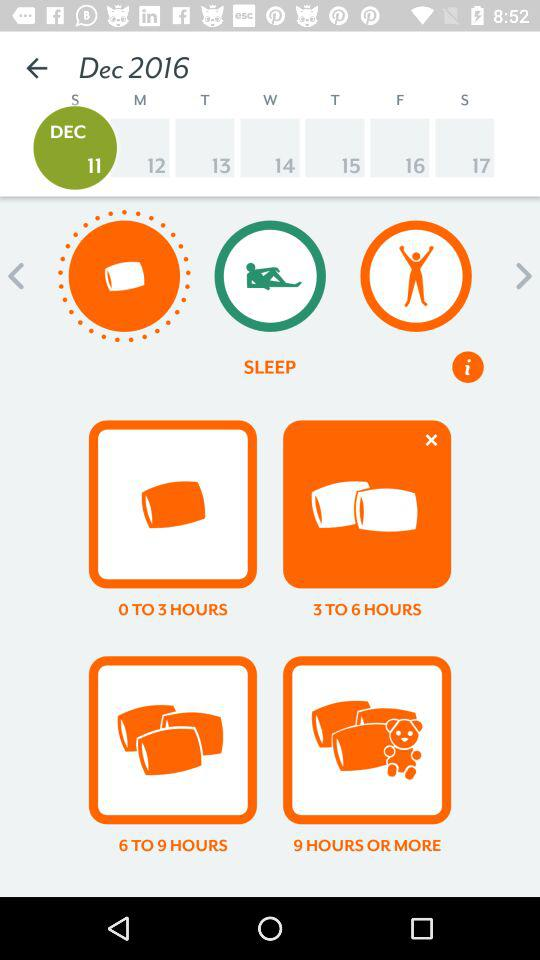How many more hours of sleep are between 3 to 6 hours and 9 hours or more?
Answer the question using a single word or phrase. 3 